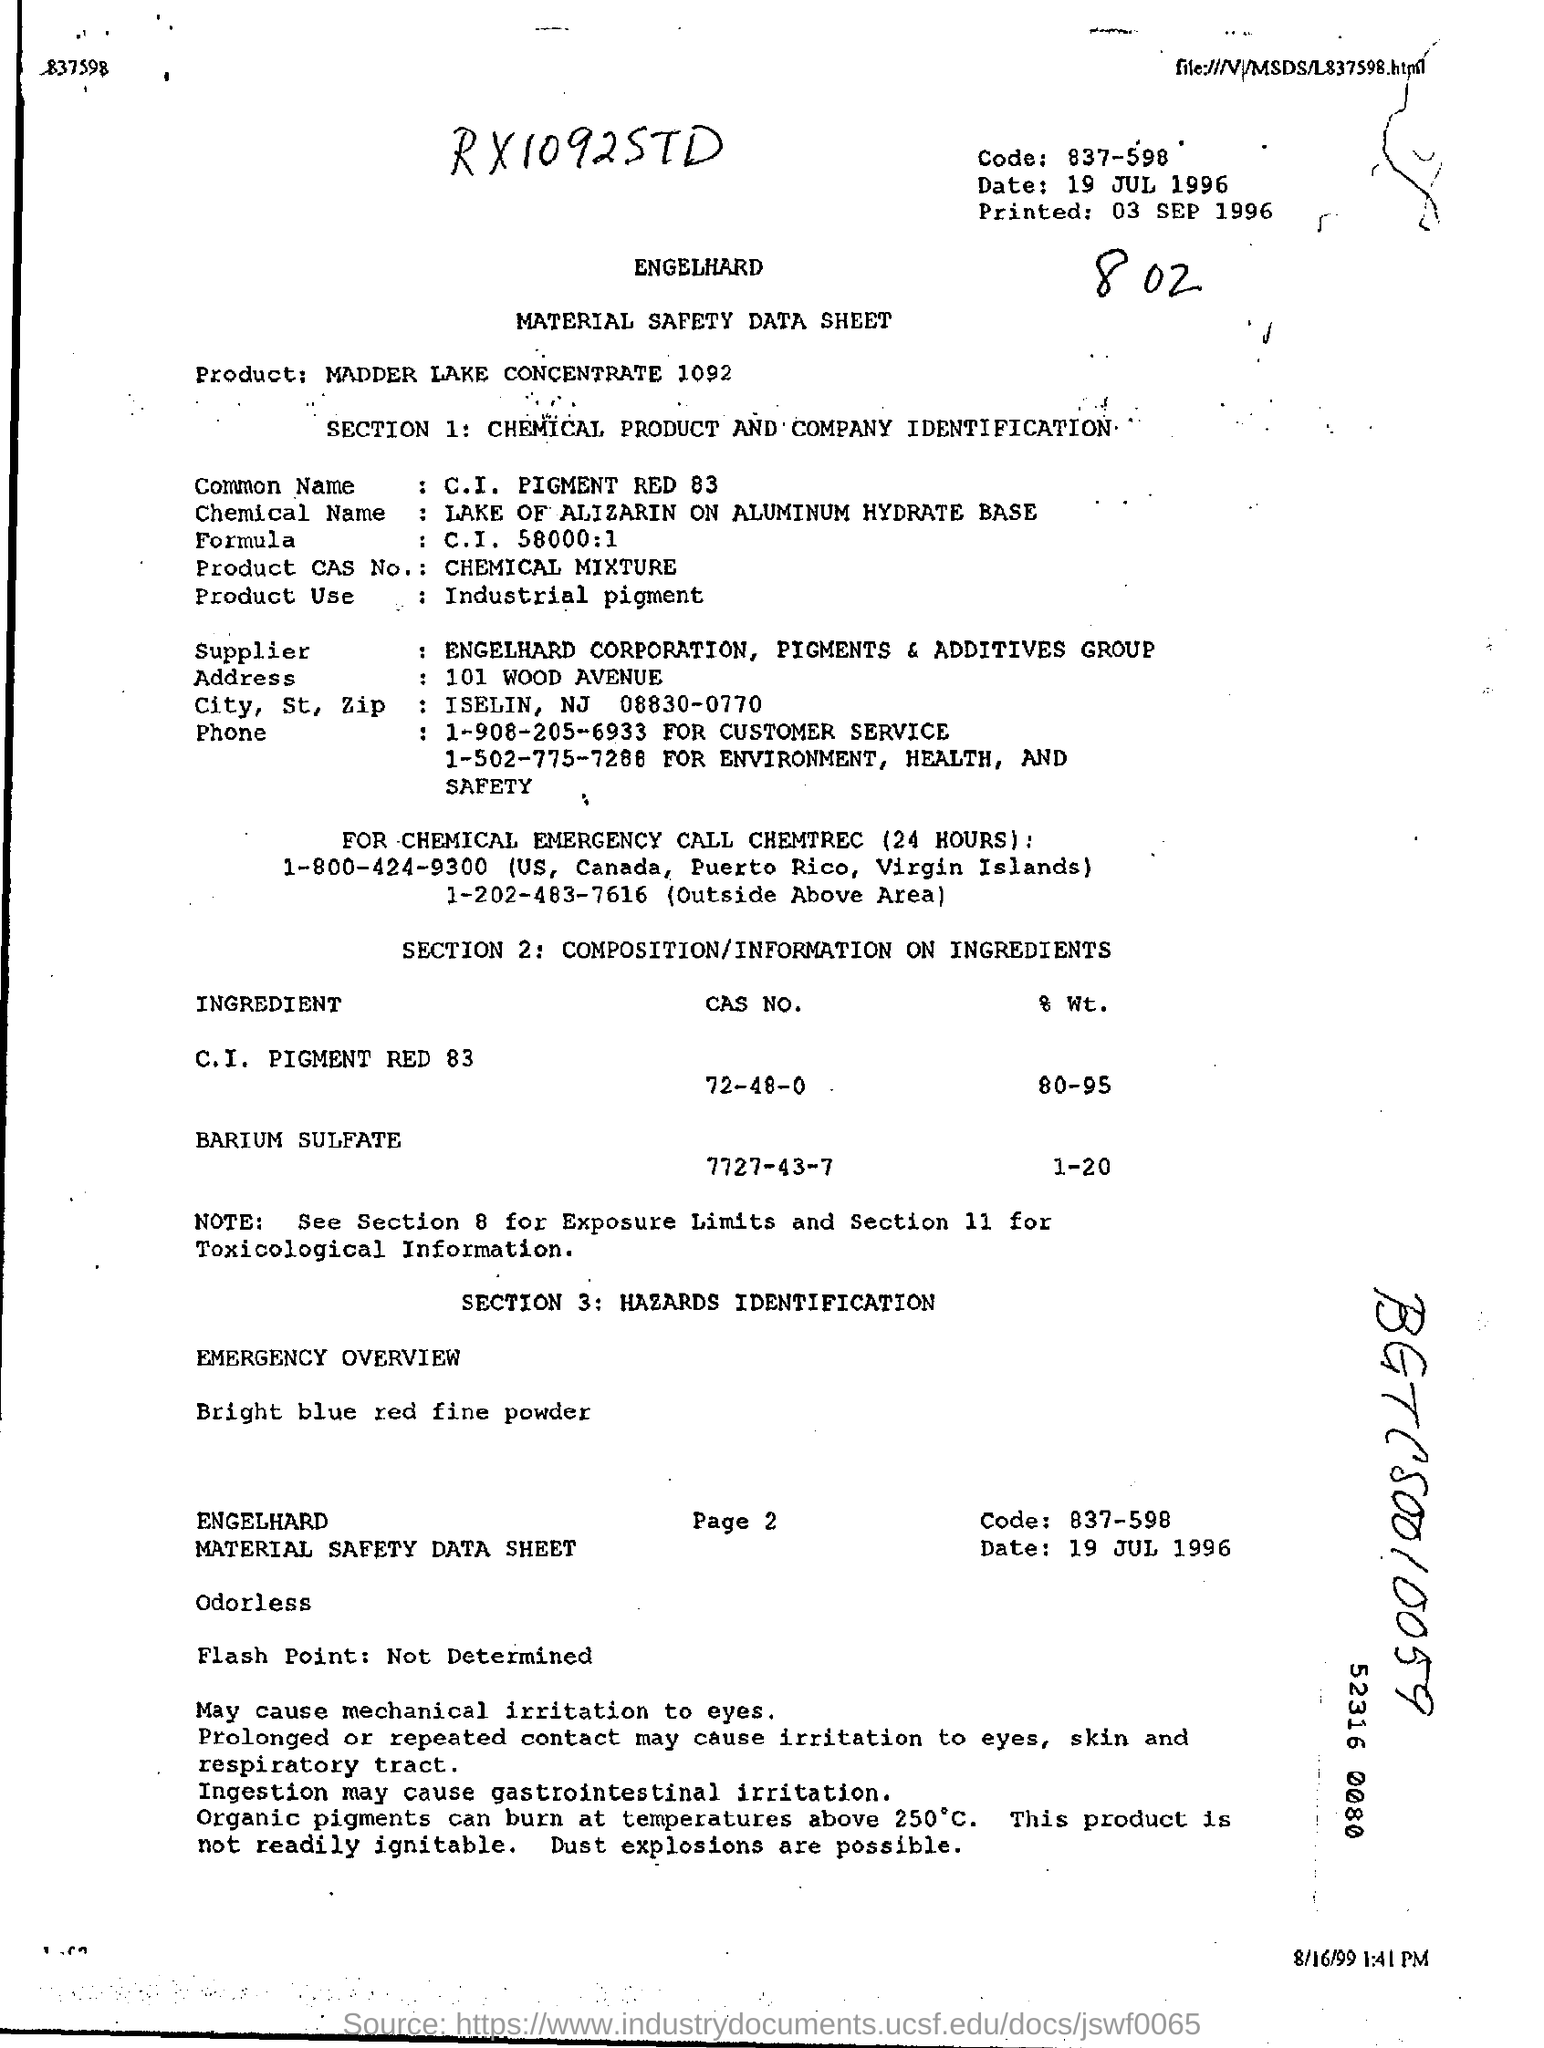Mention a couple of crucial points in this snapshot. The printed sheet is expected to be printed on September 3rd, 1996. The product mentioned is Madder Lake Concentrate 1092. The flash point of the sample has not been determined. 